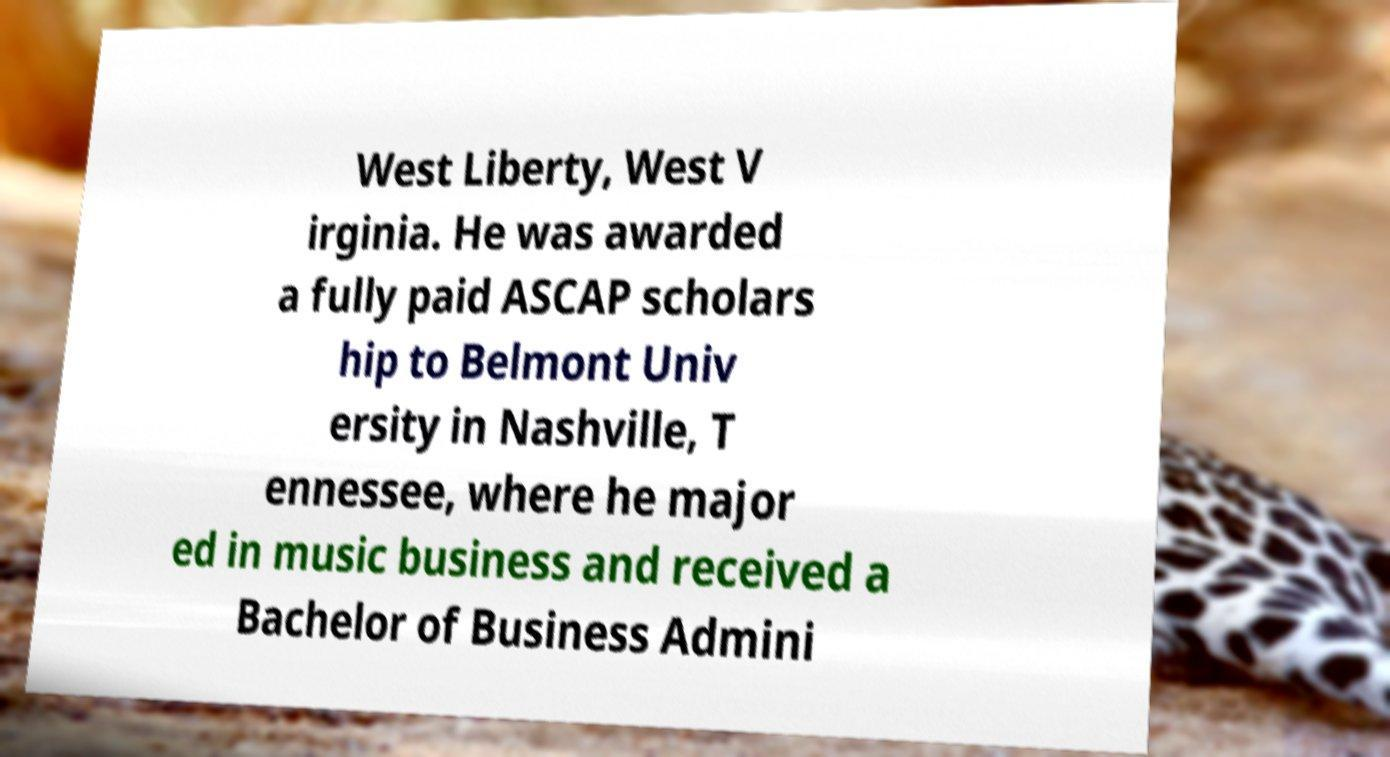Please identify and transcribe the text found in this image. West Liberty, West V irginia. He was awarded a fully paid ASCAP scholars hip to Belmont Univ ersity in Nashville, T ennessee, where he major ed in music business and received a Bachelor of Business Admini 